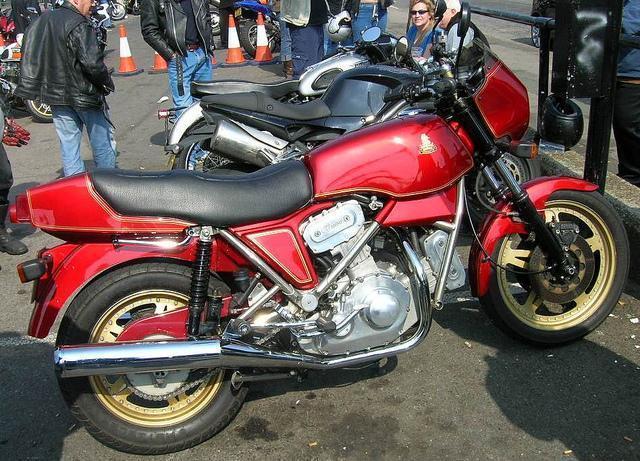How many orange cones are in the street?
Give a very brief answer. 5. How many people are in the photo?
Give a very brief answer. 4. How many motorcycles are visible?
Give a very brief answer. 2. How many computer keyboards do you see?
Give a very brief answer. 0. 